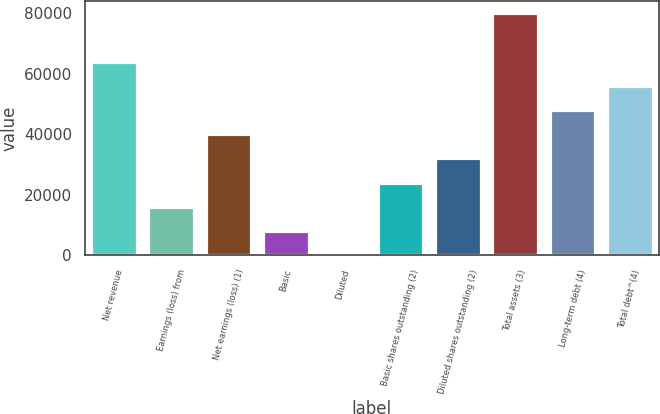Convert chart. <chart><loc_0><loc_0><loc_500><loc_500><bar_chart><fcel>Net revenue<fcel>Earnings (loss) from<fcel>Net earnings (loss) (1)<fcel>Basic<fcel>Diluted<fcel>Basic shares outstanding (2)<fcel>Diluted shares outstanding (2)<fcel>Total assets (3)<fcel>Long-term debt (4)<fcel>Total debt^(4)<nl><fcel>63933.1<fcel>15984.3<fcel>39958.7<fcel>7992.81<fcel>1.34<fcel>23975.8<fcel>31967.2<fcel>79916<fcel>47950.2<fcel>55941.6<nl></chart> 